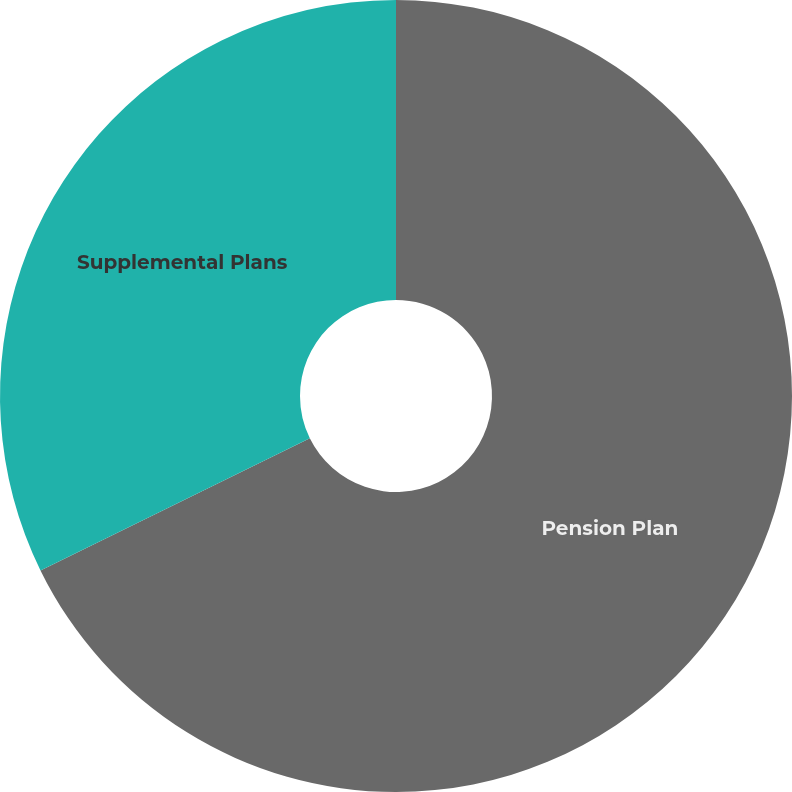Convert chart to OTSL. <chart><loc_0><loc_0><loc_500><loc_500><pie_chart><fcel>Pension Plan<fcel>Supplemental Plans<nl><fcel>67.74%<fcel>32.26%<nl></chart> 